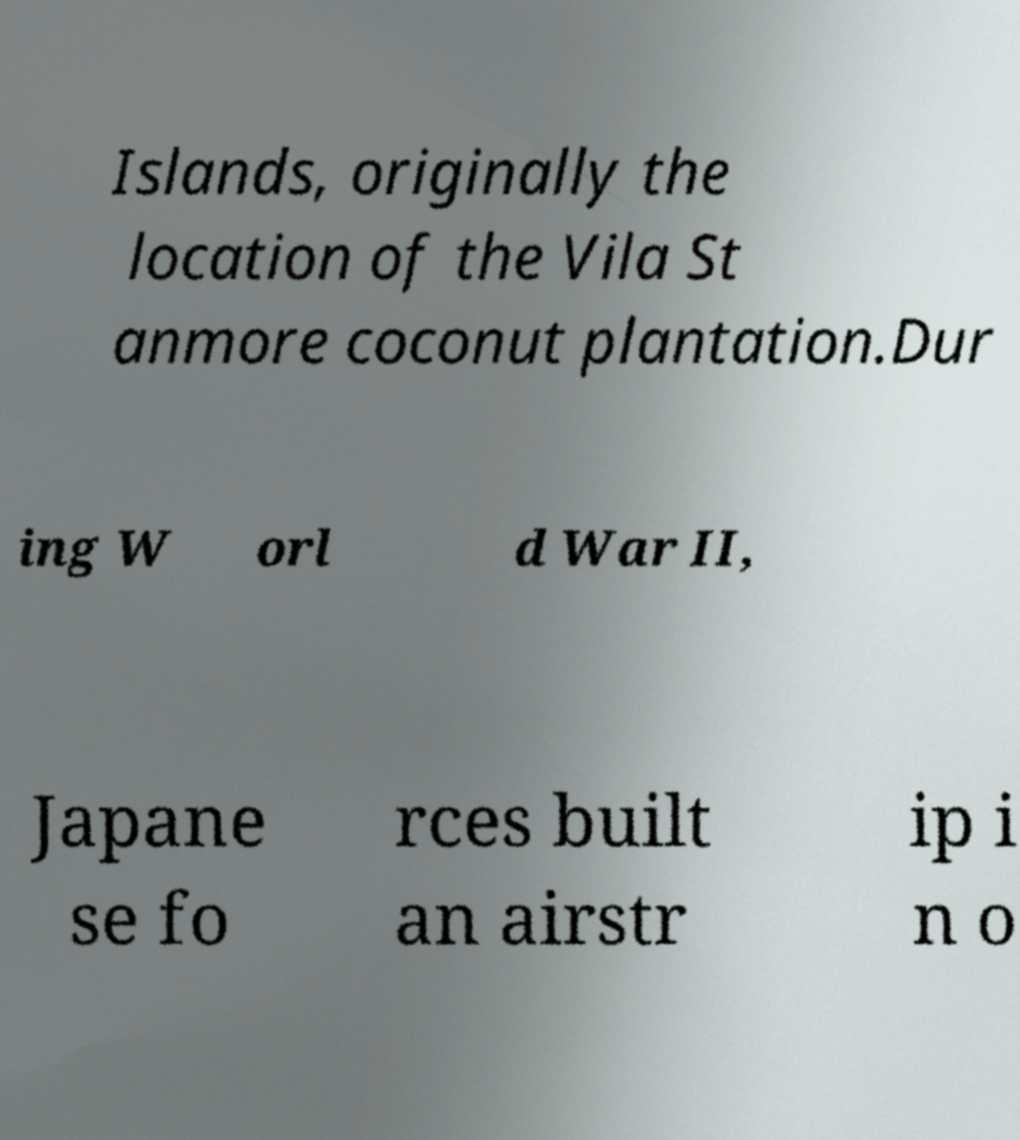Please identify and transcribe the text found in this image. Islands, originally the location of the Vila St anmore coconut plantation.Dur ing W orl d War II, Japane se fo rces built an airstr ip i n o 